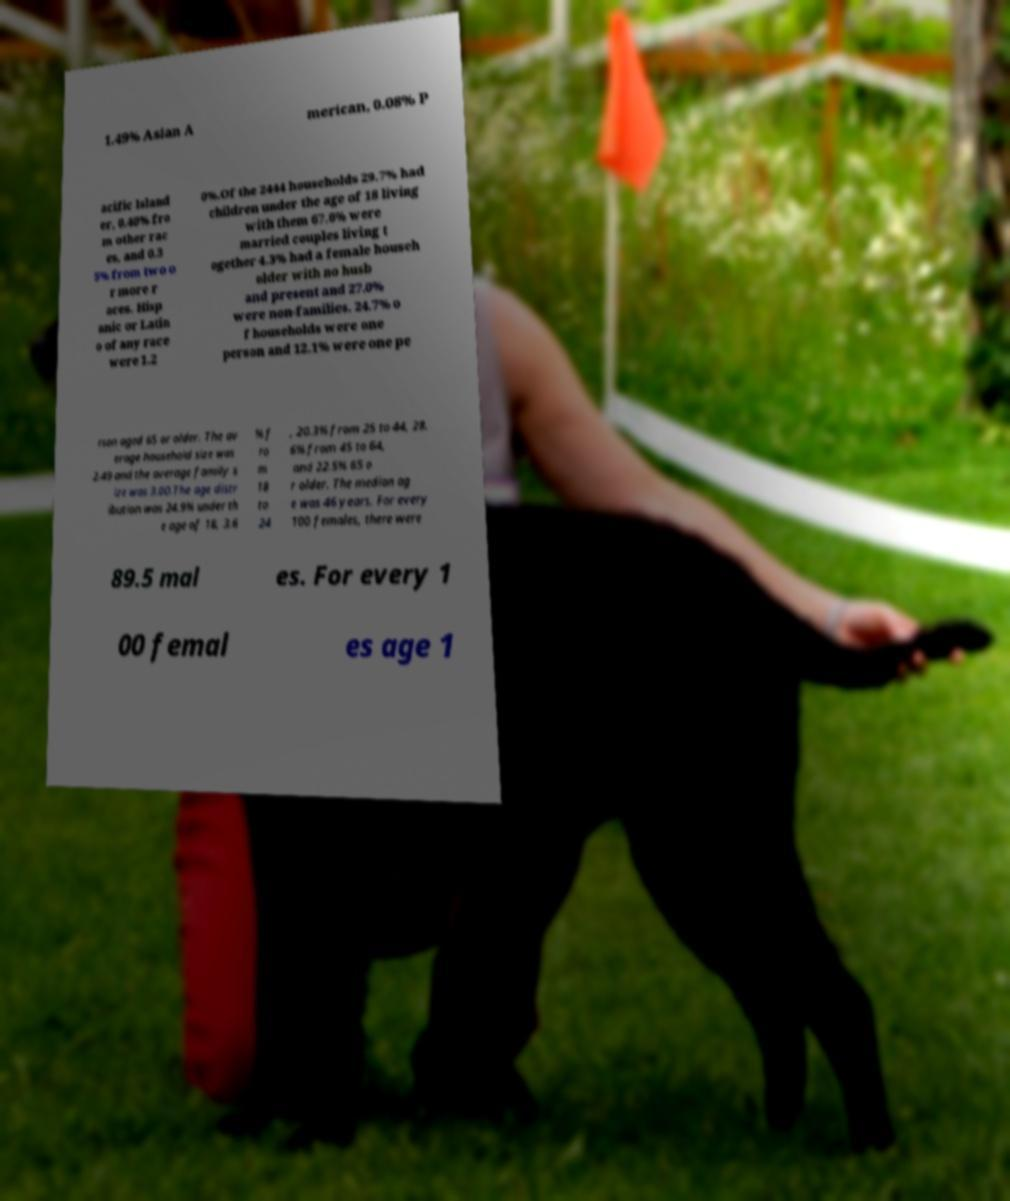Please identify and transcribe the text found in this image. 1.49% Asian A merican, 0.08% P acific Island er, 0.40% fro m other rac es, and 0.3 5% from two o r more r aces. Hisp anic or Latin o of any race were 1.2 0%.Of the 2444 households 29.7% had children under the age of 18 living with them 67.6% were married couples living t ogether 4.3% had a female househ older with no husb and present and 27.0% were non-families. 24.7% o f households were one person and 12.1% were one pe rson aged 65 or older. The av erage household size was 2.49 and the average family s ize was 3.00.The age distr ibution was 24.9% under th e age of 18, 3.6 % f ro m 18 to 24 , 20.3% from 25 to 44, 28. 6% from 45 to 64, and 22.5% 65 o r older. The median ag e was 46 years. For every 100 females, there were 89.5 mal es. For every 1 00 femal es age 1 